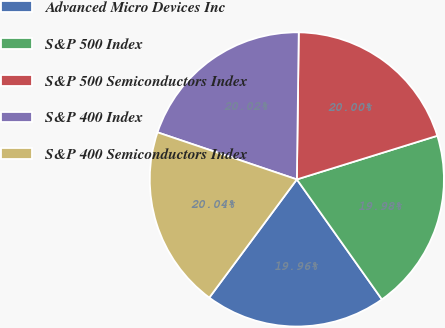Convert chart to OTSL. <chart><loc_0><loc_0><loc_500><loc_500><pie_chart><fcel>Advanced Micro Devices Inc<fcel>S&P 500 Index<fcel>S&P 500 Semiconductors Index<fcel>S&P 400 Index<fcel>S&P 400 Semiconductors Index<nl><fcel>19.96%<fcel>19.98%<fcel>20.0%<fcel>20.02%<fcel>20.04%<nl></chart> 